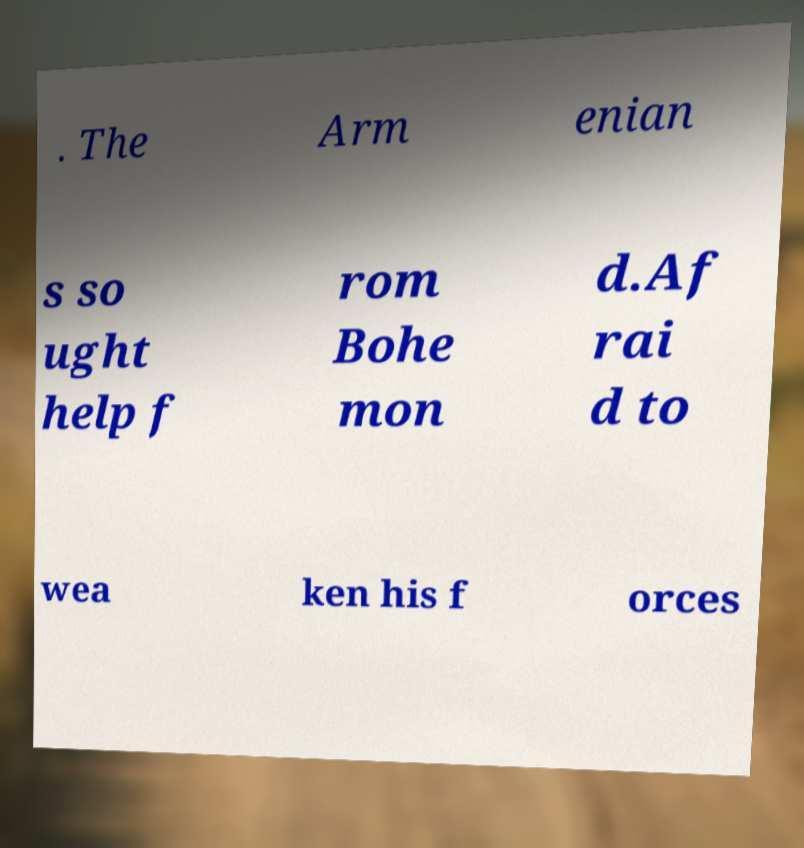Can you accurately transcribe the text from the provided image for me? . The Arm enian s so ught help f rom Bohe mon d.Af rai d to wea ken his f orces 